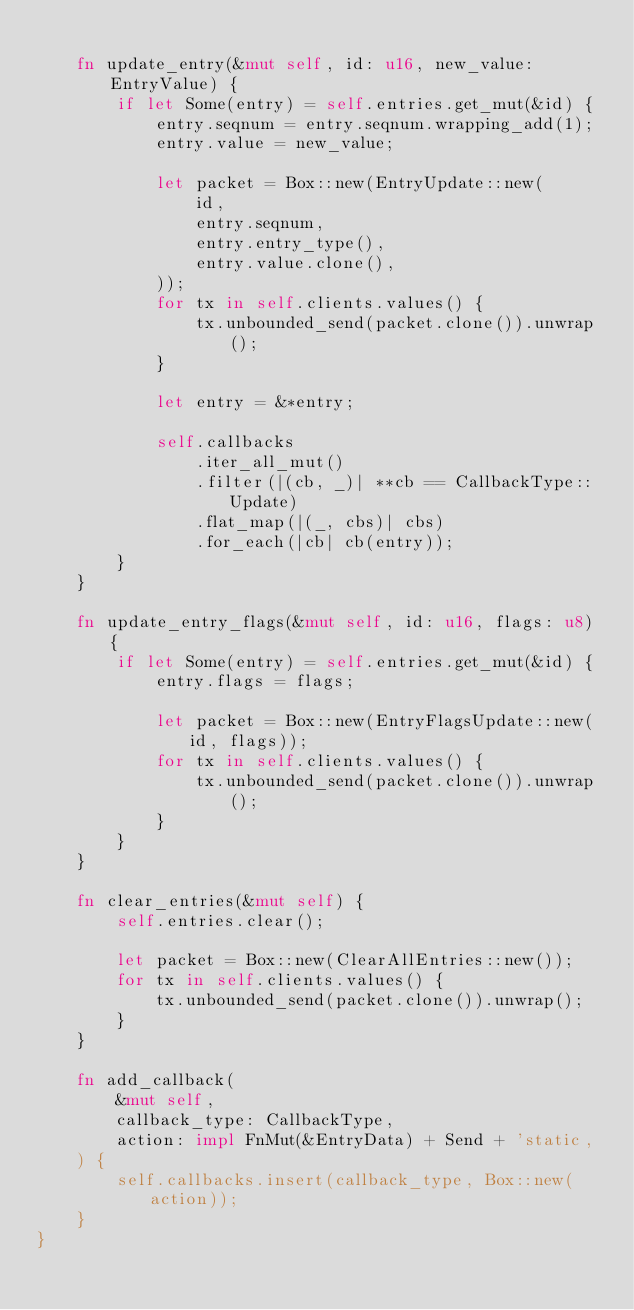<code> <loc_0><loc_0><loc_500><loc_500><_Rust_>
    fn update_entry(&mut self, id: u16, new_value: EntryValue) {
        if let Some(entry) = self.entries.get_mut(&id) {
            entry.seqnum = entry.seqnum.wrapping_add(1);
            entry.value = new_value;

            let packet = Box::new(EntryUpdate::new(
                id,
                entry.seqnum,
                entry.entry_type(),
                entry.value.clone(),
            ));
            for tx in self.clients.values() {
                tx.unbounded_send(packet.clone()).unwrap();
            }

            let entry = &*entry;

            self.callbacks
                .iter_all_mut()
                .filter(|(cb, _)| **cb == CallbackType::Update)
                .flat_map(|(_, cbs)| cbs)
                .for_each(|cb| cb(entry));
        }
    }

    fn update_entry_flags(&mut self, id: u16, flags: u8) {
        if let Some(entry) = self.entries.get_mut(&id) {
            entry.flags = flags;

            let packet = Box::new(EntryFlagsUpdate::new(id, flags));
            for tx in self.clients.values() {
                tx.unbounded_send(packet.clone()).unwrap();
            }
        }
    }

    fn clear_entries(&mut self) {
        self.entries.clear();

        let packet = Box::new(ClearAllEntries::new());
        for tx in self.clients.values() {
            tx.unbounded_send(packet.clone()).unwrap();
        }
    }

    fn add_callback(
        &mut self,
        callback_type: CallbackType,
        action: impl FnMut(&EntryData) + Send + 'static,
    ) {
        self.callbacks.insert(callback_type, Box::new(action));
    }
}
</code> 